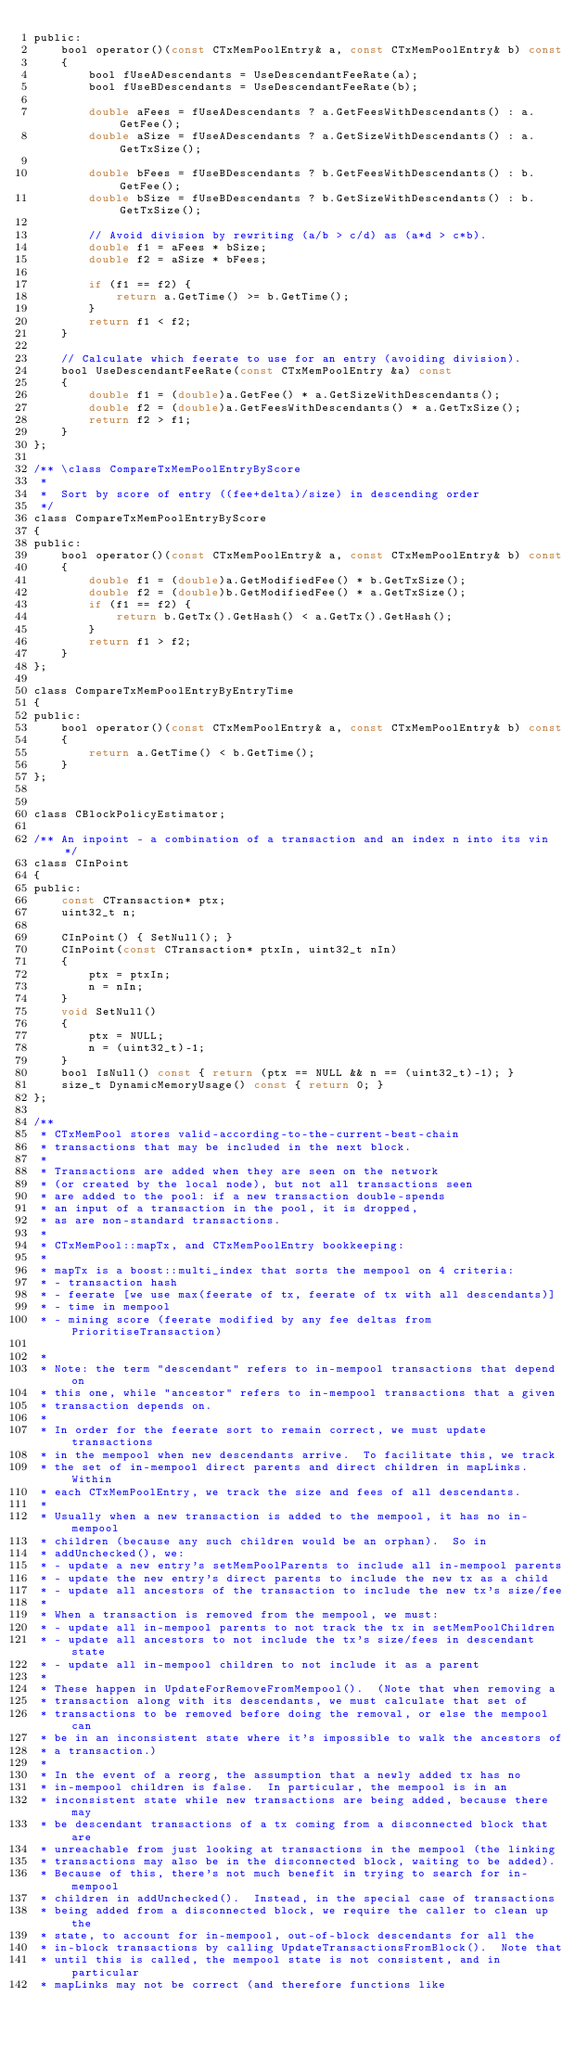<code> <loc_0><loc_0><loc_500><loc_500><_C_>public:
    bool operator()(const CTxMemPoolEntry& a, const CTxMemPoolEntry& b) const
    {
        bool fUseADescendants = UseDescendantFeeRate(a);
        bool fUseBDescendants = UseDescendantFeeRate(b);

        double aFees = fUseADescendants ? a.GetFeesWithDescendants() : a.GetFee();
        double aSize = fUseADescendants ? a.GetSizeWithDescendants() : a.GetTxSize();

        double bFees = fUseBDescendants ? b.GetFeesWithDescendants() : b.GetFee();
        double bSize = fUseBDescendants ? b.GetSizeWithDescendants() : b.GetTxSize();

        // Avoid division by rewriting (a/b > c/d) as (a*d > c*b).
        double f1 = aFees * bSize;
        double f2 = aSize * bFees;

        if (f1 == f2) {
            return a.GetTime() >= b.GetTime();
        }
        return f1 < f2;
    }

    // Calculate which feerate to use for an entry (avoiding division).
    bool UseDescendantFeeRate(const CTxMemPoolEntry &a) const
    {
        double f1 = (double)a.GetFee() * a.GetSizeWithDescendants();
        double f2 = (double)a.GetFeesWithDescendants() * a.GetTxSize();
        return f2 > f1;
    }
};

/** \class CompareTxMemPoolEntryByScore
 *
 *  Sort by score of entry ((fee+delta)/size) in descending order
 */
class CompareTxMemPoolEntryByScore
{
public:
    bool operator()(const CTxMemPoolEntry& a, const CTxMemPoolEntry& b) const
    {
        double f1 = (double)a.GetModifiedFee() * b.GetTxSize();
        double f2 = (double)b.GetModifiedFee() * a.GetTxSize();
        if (f1 == f2) {
            return b.GetTx().GetHash() < a.GetTx().GetHash();
        }
        return f1 > f2;
    }
};

class CompareTxMemPoolEntryByEntryTime
{
public:
    bool operator()(const CTxMemPoolEntry& a, const CTxMemPoolEntry& b) const
    {
        return a.GetTime() < b.GetTime();
    }
};


class CBlockPolicyEstimator;

/** An inpoint - a combination of a transaction and an index n into its vin */
class CInPoint
{
public:
    const CTransaction* ptx;
    uint32_t n;

    CInPoint() { SetNull(); }
    CInPoint(const CTransaction* ptxIn, uint32_t nIn)
    {
        ptx = ptxIn;
        n = nIn;
    }
    void SetNull()
    {
        ptx = NULL;
        n = (uint32_t)-1;
    }
    bool IsNull() const { return (ptx == NULL && n == (uint32_t)-1); }
    size_t DynamicMemoryUsage() const { return 0; }
};

/**
 * CTxMemPool stores valid-according-to-the-current-best-chain
 * transactions that may be included in the next block.
 *
 * Transactions are added when they are seen on the network
 * (or created by the local node), but not all transactions seen
 * are added to the pool: if a new transaction double-spends
 * an input of a transaction in the pool, it is dropped,
 * as are non-standard transactions.
 *
 * CTxMemPool::mapTx, and CTxMemPoolEntry bookkeeping:
 *
 * mapTx is a boost::multi_index that sorts the mempool on 4 criteria:
 * - transaction hash
 * - feerate [we use max(feerate of tx, feerate of tx with all descendants)]
 * - time in mempool
 * - mining score (feerate modified by any fee deltas from PrioritiseTransaction)

 *
 * Note: the term "descendant" refers to in-mempool transactions that depend on
 * this one, while "ancestor" refers to in-mempool transactions that a given
 * transaction depends on.
 *
 * In order for the feerate sort to remain correct, we must update transactions
 * in the mempool when new descendants arrive.  To facilitate this, we track
 * the set of in-mempool direct parents and direct children in mapLinks.  Within
 * each CTxMemPoolEntry, we track the size and fees of all descendants.
 *
 * Usually when a new transaction is added to the mempool, it has no in-mempool
 * children (because any such children would be an orphan).  So in
 * addUnchecked(), we:
 * - update a new entry's setMemPoolParents to include all in-mempool parents
 * - update the new entry's direct parents to include the new tx as a child
 * - update all ancestors of the transaction to include the new tx's size/fee
 *
 * When a transaction is removed from the mempool, we must:
 * - update all in-mempool parents to not track the tx in setMemPoolChildren
 * - update all ancestors to not include the tx's size/fees in descendant state
 * - update all in-mempool children to not include it as a parent
 *
 * These happen in UpdateForRemoveFromMempool().  (Note that when removing a
 * transaction along with its descendants, we must calculate that set of
 * transactions to be removed before doing the removal, or else the mempool can
 * be in an inconsistent state where it's impossible to walk the ancestors of
 * a transaction.)
 *
 * In the event of a reorg, the assumption that a newly added tx has no
 * in-mempool children is false.  In particular, the mempool is in an
 * inconsistent state while new transactions are being added, because there may
 * be descendant transactions of a tx coming from a disconnected block that are
 * unreachable from just looking at transactions in the mempool (the linking
 * transactions may also be in the disconnected block, waiting to be added).
 * Because of this, there's not much benefit in trying to search for in-mempool
 * children in addUnchecked().  Instead, in the special case of transactions
 * being added from a disconnected block, we require the caller to clean up the
 * state, to account for in-mempool, out-of-block descendants for all the
 * in-block transactions by calling UpdateTransactionsFromBlock().  Note that
 * until this is called, the mempool state is not consistent, and in particular
 * mapLinks may not be correct (and therefore functions like</code> 